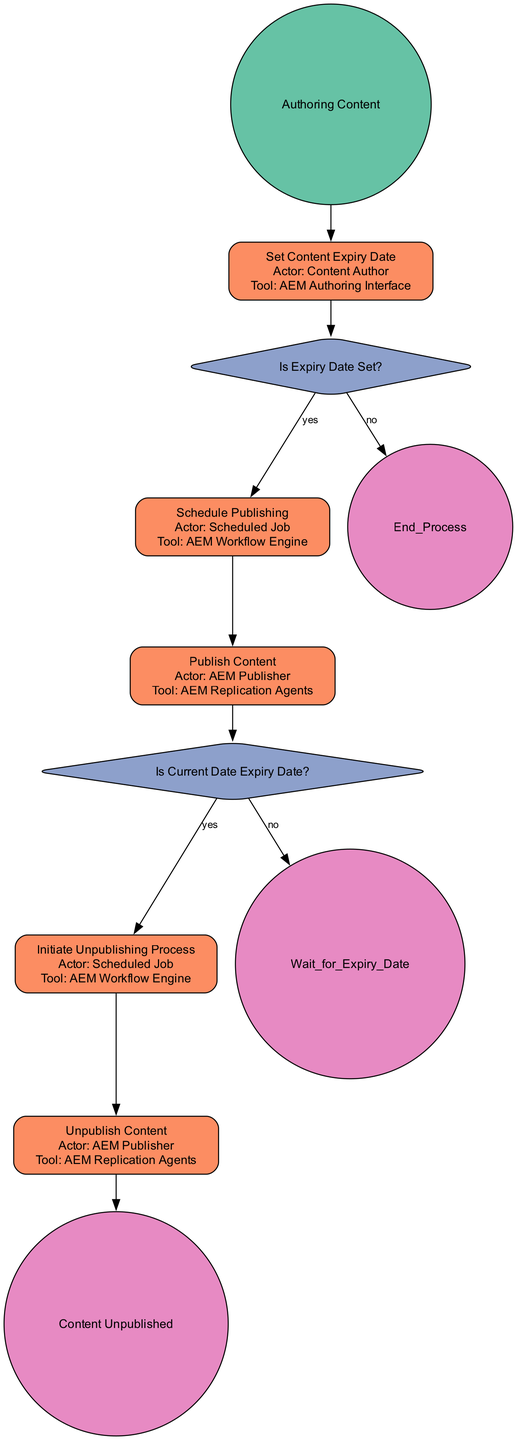What is the first step in the workflow? The first step in the workflow is represented by the start event, which is labeled "Authoring Content." This indicates the process begins with creating content.
Answer: Authoring Content What decision is made after setting the content expiry date? The decision made is whether the expiry date is set or not. If it is set, the process moves to "Schedule Publishing"; if not, it ends the process.
Answer: Is Expiry Date Set? Who is responsible for publishing the content? The actor responsible for publishing the content is indicated in the "Publish Content" activity, which states the actor is "AEM Publisher."
Answer: AEM Publisher How many activities are present in the diagram? The diagram presents three main activities: "Set Content Expiry Date," "Schedule Publishing," and "Publish Content," and later activities for unpublishing as well. Counting both publishing and unpublishing activities gives a total of five distinct activities.
Answer: Five What happens if the current date is not the expiry date? If the current date is not the expiry date, the process will lead to the "Wait for Expiry Date" element, indicating a pause until the expiry date occurs.
Answer: Wait for Expiry Date What is the end event of the process? The end event signifies the completion of the workflow and is labeled "Content Unpublished." This indicates that the content lifecycle has concluded with the final action of unpublishing.
Answer: Content Unpublished What initiates the unpublishing process? The unpublishing process is initiated by the activity labeled "Initiate Unpublishing Process," which is triggered when the current date matches the expiry date.
Answer: Initiate Unpublishing Process Which tool is utilized for the scheduling of publishing? The tool used for scheduling publishing is identified in the "Schedule Publishing" activity, which states that the "AEM Workflow Engine" is employed for this purpose.
Answer: AEM Workflow Engine 